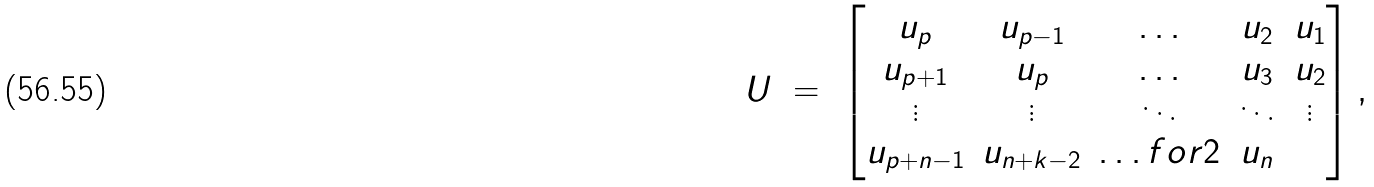<formula> <loc_0><loc_0><loc_500><loc_500>U \ = \ \begin{bmatrix} u _ { p } & u _ { p - 1 } & \hdots & u _ { 2 } & u _ { 1 } \\ u _ { p + 1 } & u _ { p } & \hdots & u _ { 3 } & u _ { 2 } \\ \vdots & \vdots & \ddots & \ddots & \vdots \\ u _ { p + n - 1 } & u _ { n + k - 2 } & \hdots f o r { 2 } & u _ { n } \end{bmatrix} ,</formula> 